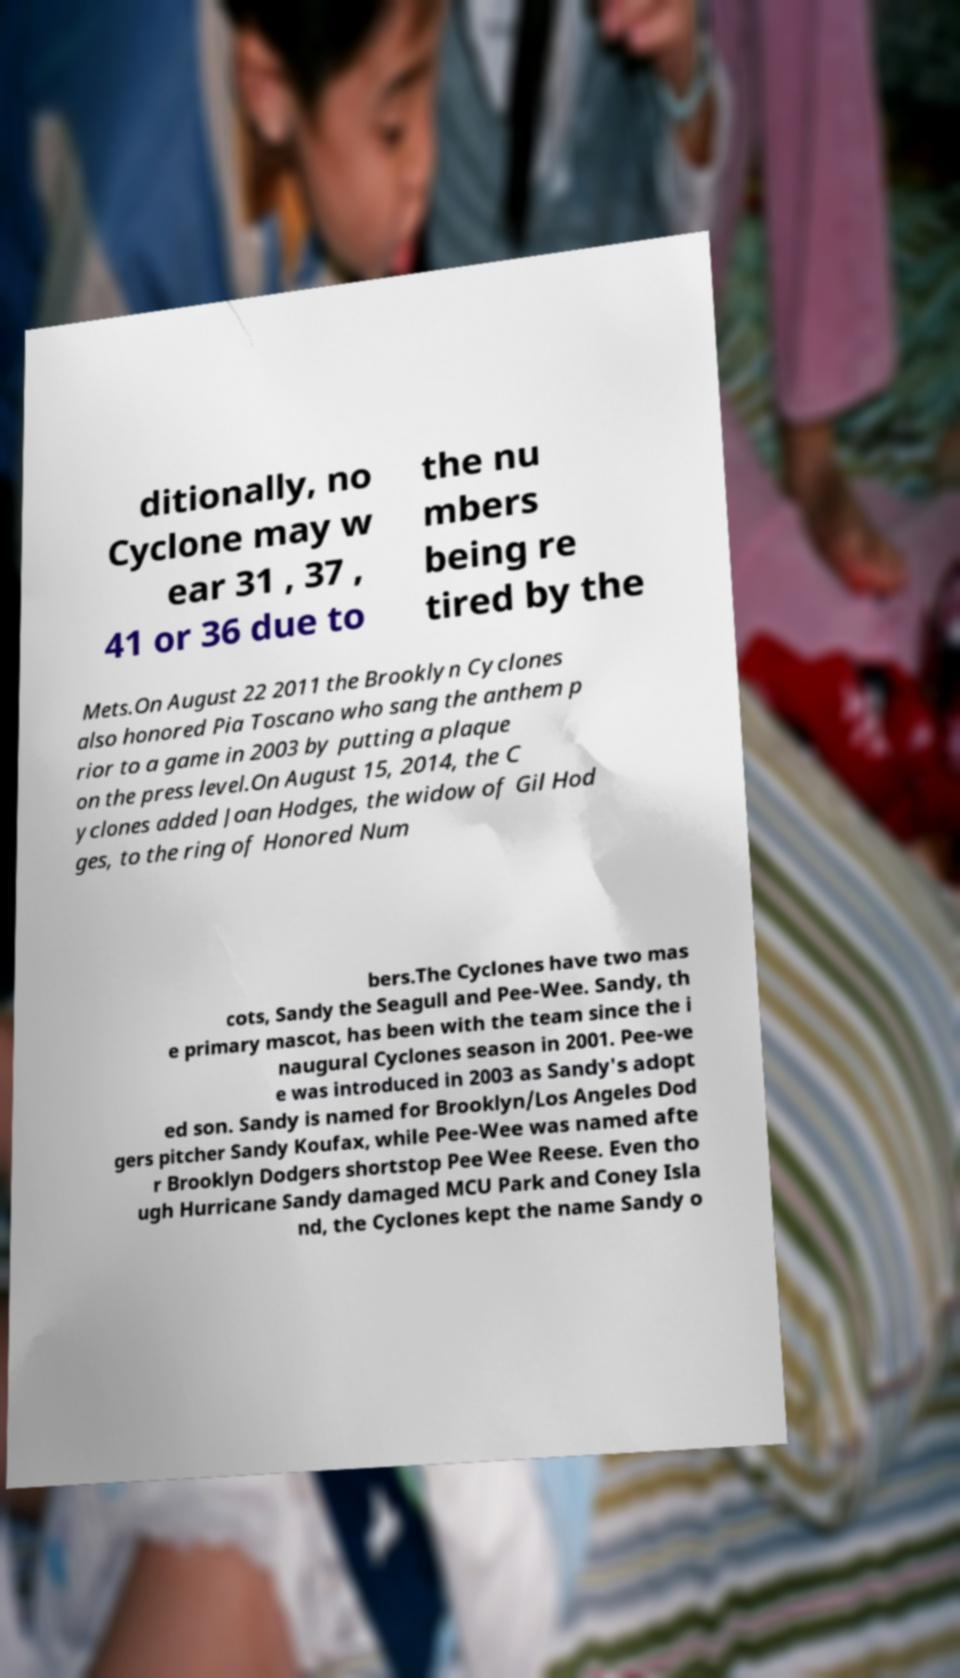For documentation purposes, I need the text within this image transcribed. Could you provide that? ditionally, no Cyclone may w ear 31 , 37 , 41 or 36 due to the nu mbers being re tired by the Mets.On August 22 2011 the Brooklyn Cyclones also honored Pia Toscano who sang the anthem p rior to a game in 2003 by putting a plaque on the press level.On August 15, 2014, the C yclones added Joan Hodges, the widow of Gil Hod ges, to the ring of Honored Num bers.The Cyclones have two mas cots, Sandy the Seagull and Pee-Wee. Sandy, th e primary mascot, has been with the team since the i naugural Cyclones season in 2001. Pee-we e was introduced in 2003 as Sandy's adopt ed son. Sandy is named for Brooklyn/Los Angeles Dod gers pitcher Sandy Koufax, while Pee-Wee was named afte r Brooklyn Dodgers shortstop Pee Wee Reese. Even tho ugh Hurricane Sandy damaged MCU Park and Coney Isla nd, the Cyclones kept the name Sandy o 